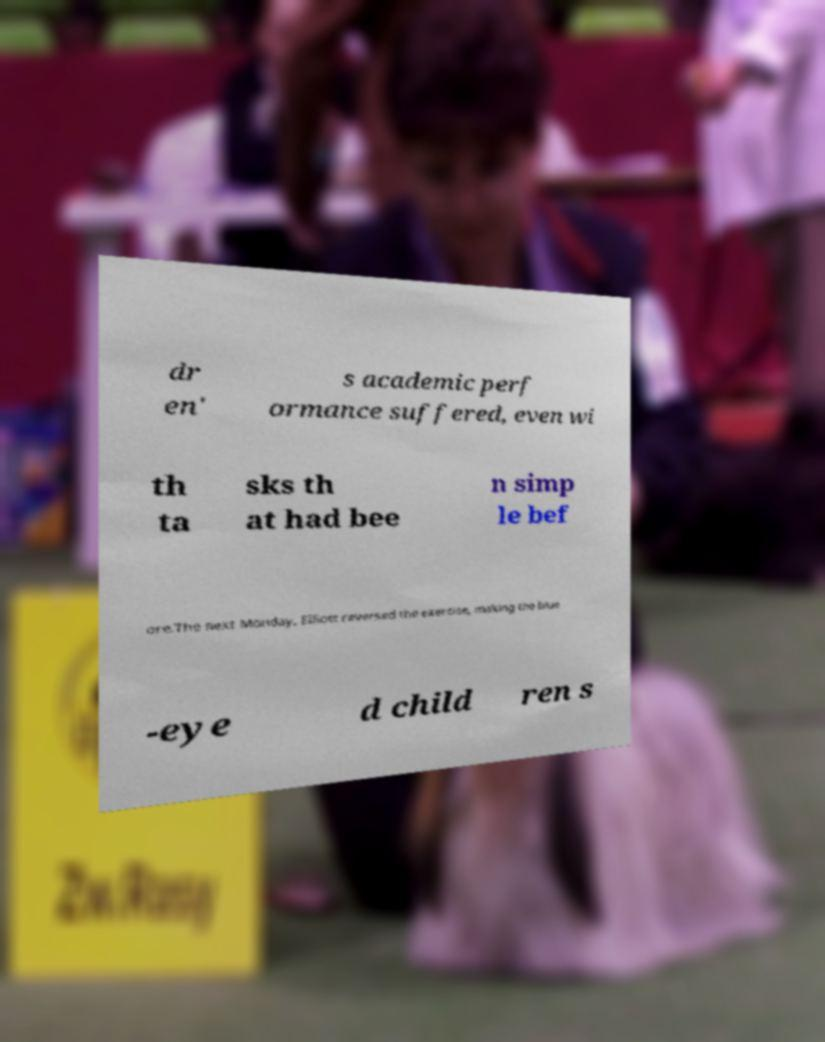Please read and relay the text visible in this image. What does it say? dr en' s academic perf ormance suffered, even wi th ta sks th at had bee n simp le bef ore.The next Monday, Elliott reversed the exercise, making the blue -eye d child ren s 